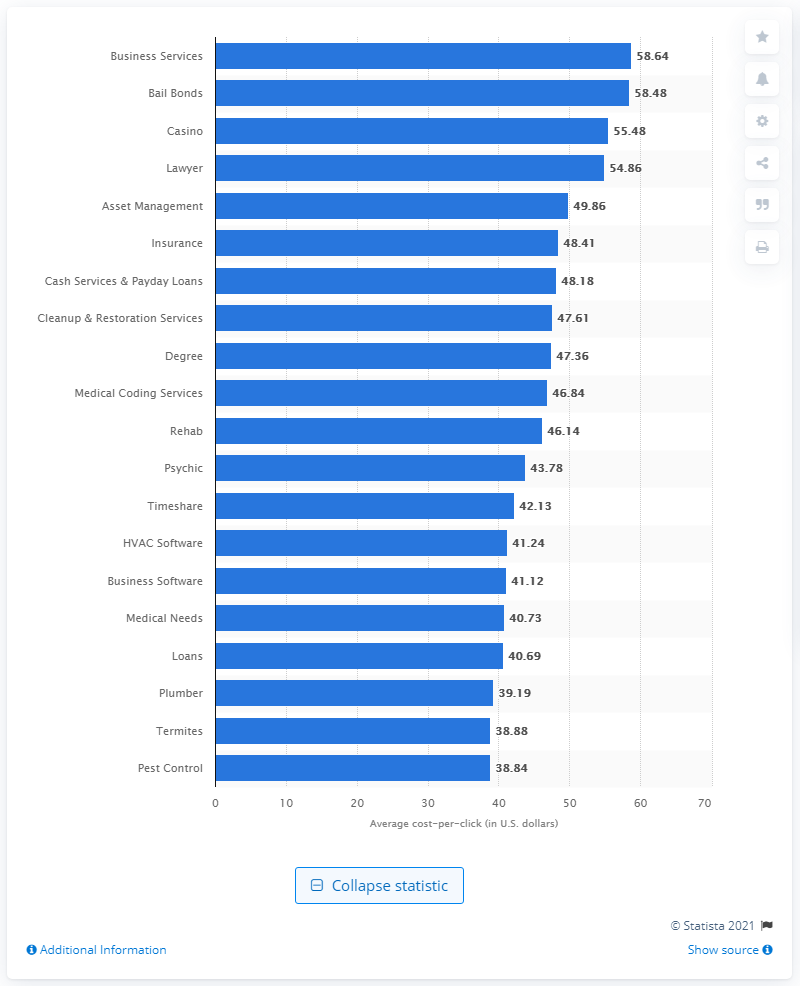Give some essential details in this illustration. The cost per click for business services was 58.64. The cost per click for the term "casino" was 55.48. 